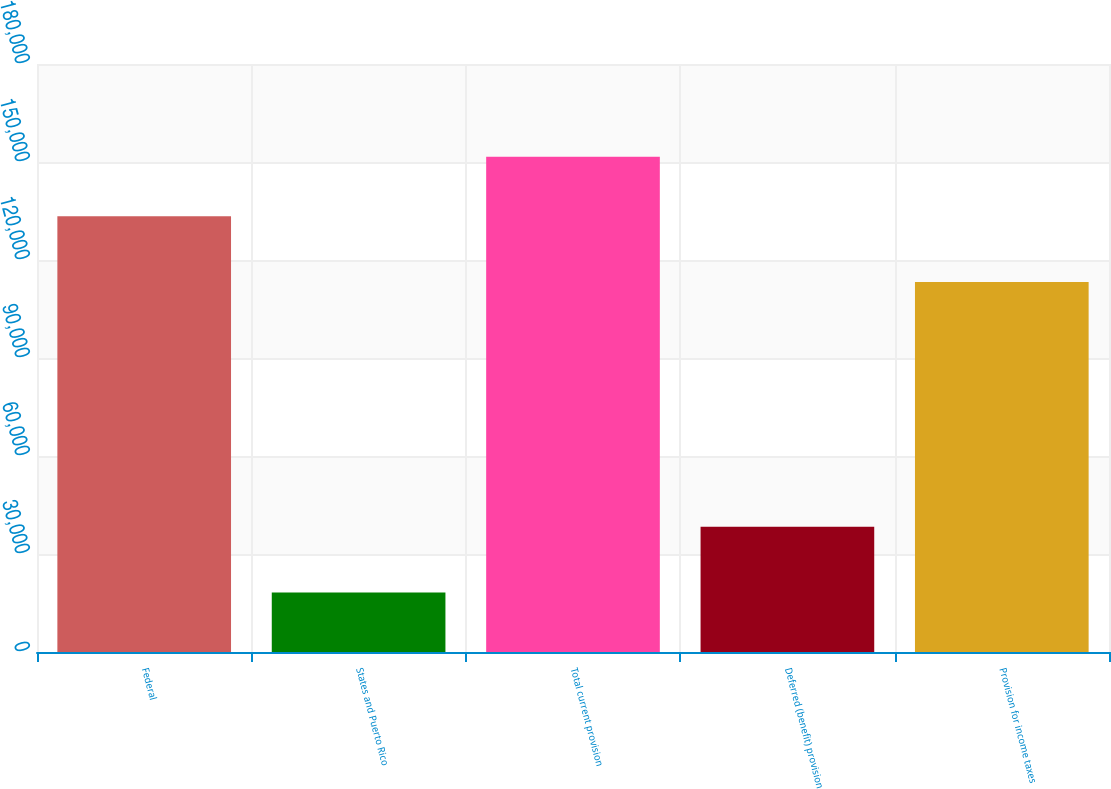Convert chart. <chart><loc_0><loc_0><loc_500><loc_500><bar_chart><fcel>Federal<fcel>States and Puerto Rico<fcel>Total current provision<fcel>Deferred (benefit) provision<fcel>Provision for income taxes<nl><fcel>133404<fcel>18189<fcel>151593<fcel>38362<fcel>113231<nl></chart> 